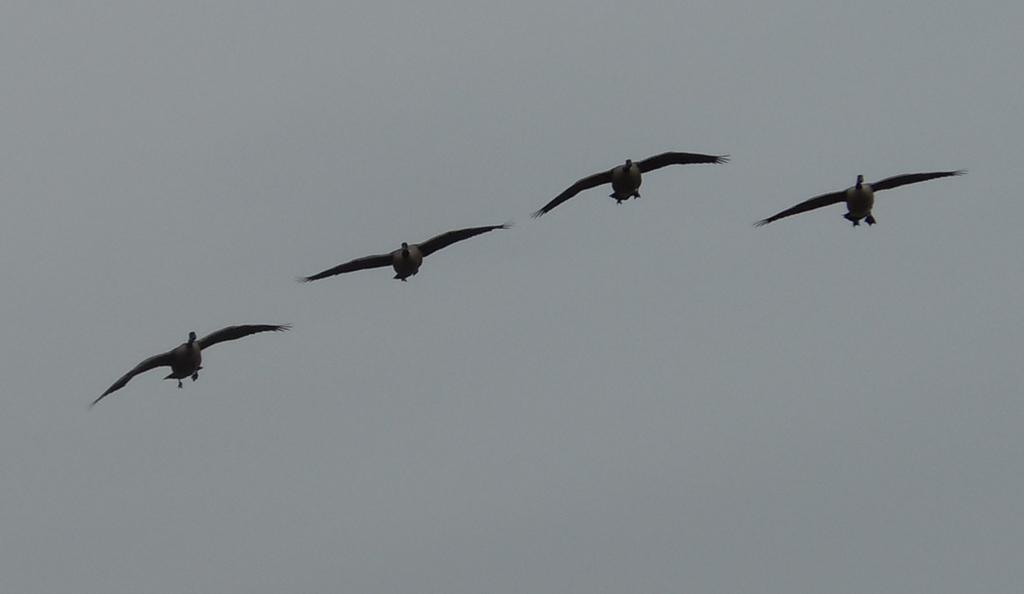In one or two sentences, can you explain what this image depicts? 4 birds are flying in an air. 